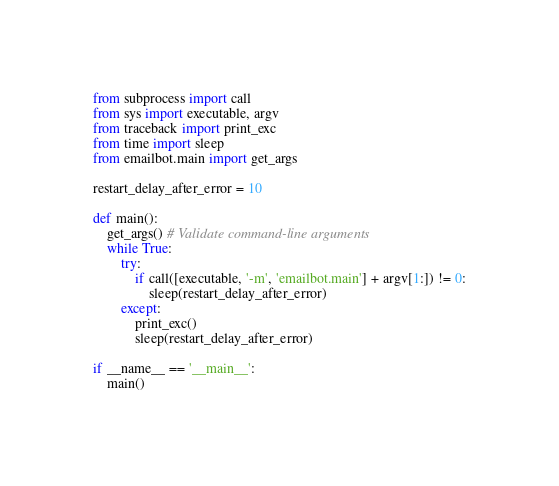<code> <loc_0><loc_0><loc_500><loc_500><_Python_>from subprocess import call
from sys import executable, argv
from traceback import print_exc
from time import sleep
from emailbot.main import get_args

restart_delay_after_error = 10

def main():
    get_args() # Validate command-line arguments
    while True:
        try:
            if call([executable, '-m', 'emailbot.main'] + argv[1:]) != 0:
                sleep(restart_delay_after_error)
        except:
            print_exc()
            sleep(restart_delay_after_error)

if __name__ == '__main__':
    main()
</code> 